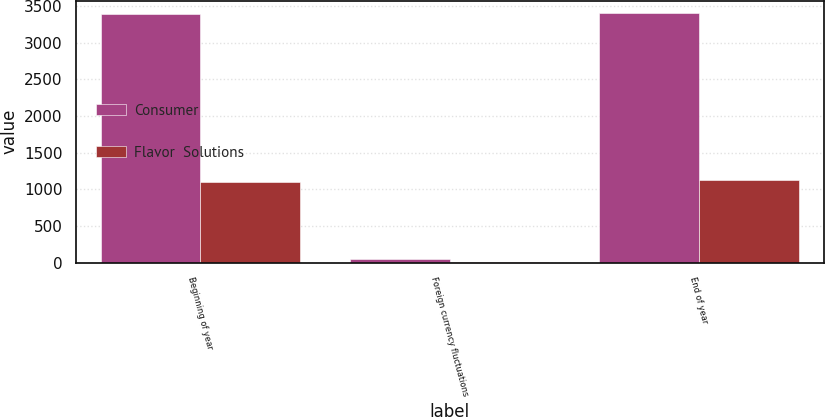<chart> <loc_0><loc_0><loc_500><loc_500><stacked_bar_chart><ecel><fcel>Beginning of year<fcel>Foreign currency fluctuations<fcel>End of year<nl><fcel>Consumer<fcel>3385.4<fcel>54.6<fcel>3398.9<nl><fcel>Flavor  Solutions<fcel>1104.7<fcel>9.8<fcel>1129<nl></chart> 